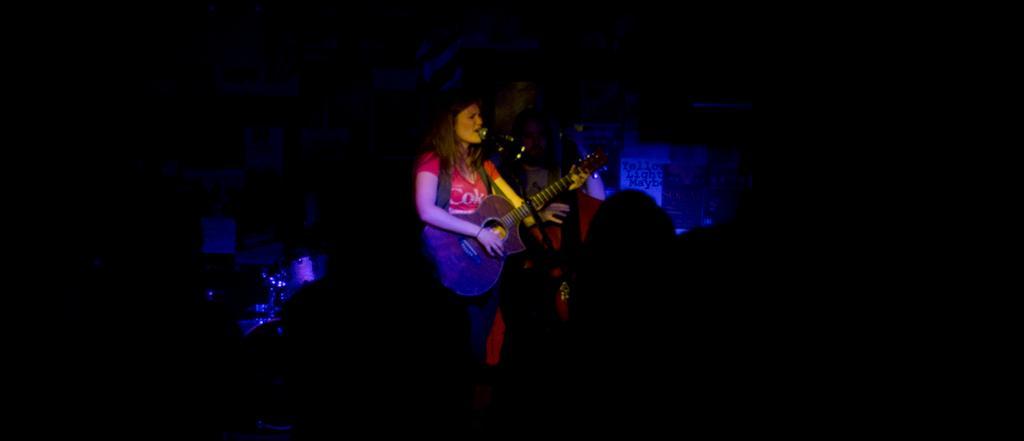In one or two sentences, can you explain what this image depicts? In this image i can see a woman is playing a guitar is playing a guitar in front of a microphone. 